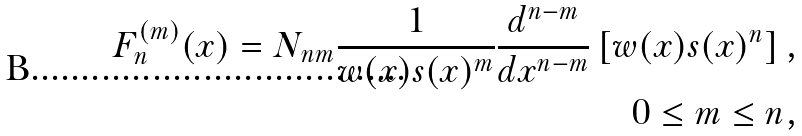Convert formula to latex. <formula><loc_0><loc_0><loc_500><loc_500>F _ { n } ^ { ( m ) } ( x ) = N _ { n m } \frac { 1 } { w ( x ) s ( x ) ^ { m } } \frac { d ^ { n - m } } { d x ^ { n - m } } \left [ w ( x ) s ( x ) ^ { n } \right ] , \\ 0 \leq m \leq n ,</formula> 